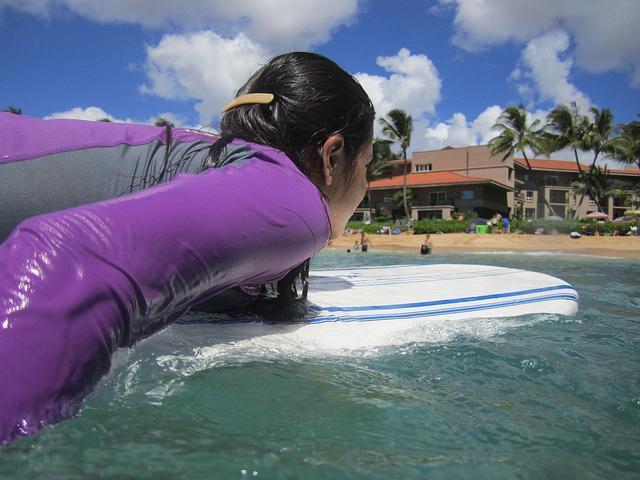How many cars can you see?
Give a very brief answer. 0. 